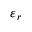Convert formula to latex. <formula><loc_0><loc_0><loc_500><loc_500>\varepsilon _ { r }</formula> 